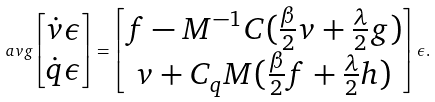<formula> <loc_0><loc_0><loc_500><loc_500>\ a v g { \begin{bmatrix} \dot { v } \epsilon \\ \dot { q } \epsilon \end{bmatrix} } = \begin{bmatrix} f - M ^ { - 1 } C ( \frac { \beta } { 2 } v + \frac { \lambda } { 2 } g ) \\ v + C _ { q } M ( \frac { \beta } { 2 } f + \frac { \lambda } { 2 } h ) \end{bmatrix} \epsilon .</formula> 